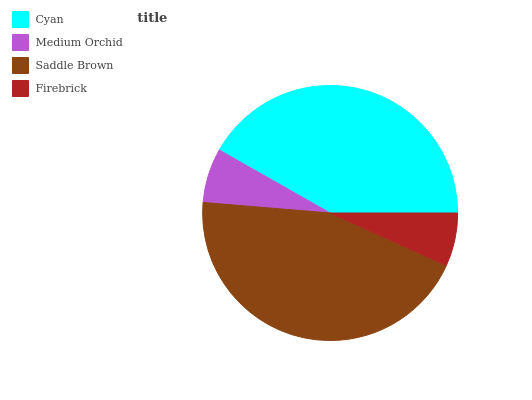Is Firebrick the minimum?
Answer yes or no. Yes. Is Saddle Brown the maximum?
Answer yes or no. Yes. Is Medium Orchid the minimum?
Answer yes or no. No. Is Medium Orchid the maximum?
Answer yes or no. No. Is Cyan greater than Medium Orchid?
Answer yes or no. Yes. Is Medium Orchid less than Cyan?
Answer yes or no. Yes. Is Medium Orchid greater than Cyan?
Answer yes or no. No. Is Cyan less than Medium Orchid?
Answer yes or no. No. Is Cyan the high median?
Answer yes or no. Yes. Is Medium Orchid the low median?
Answer yes or no. Yes. Is Medium Orchid the high median?
Answer yes or no. No. Is Saddle Brown the low median?
Answer yes or no. No. 